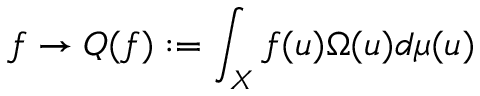<formula> <loc_0><loc_0><loc_500><loc_500>f \rightarrow Q ( f ) \colon = \int _ { X } f ( u ) \Omega ( u ) d \mu ( u )</formula> 